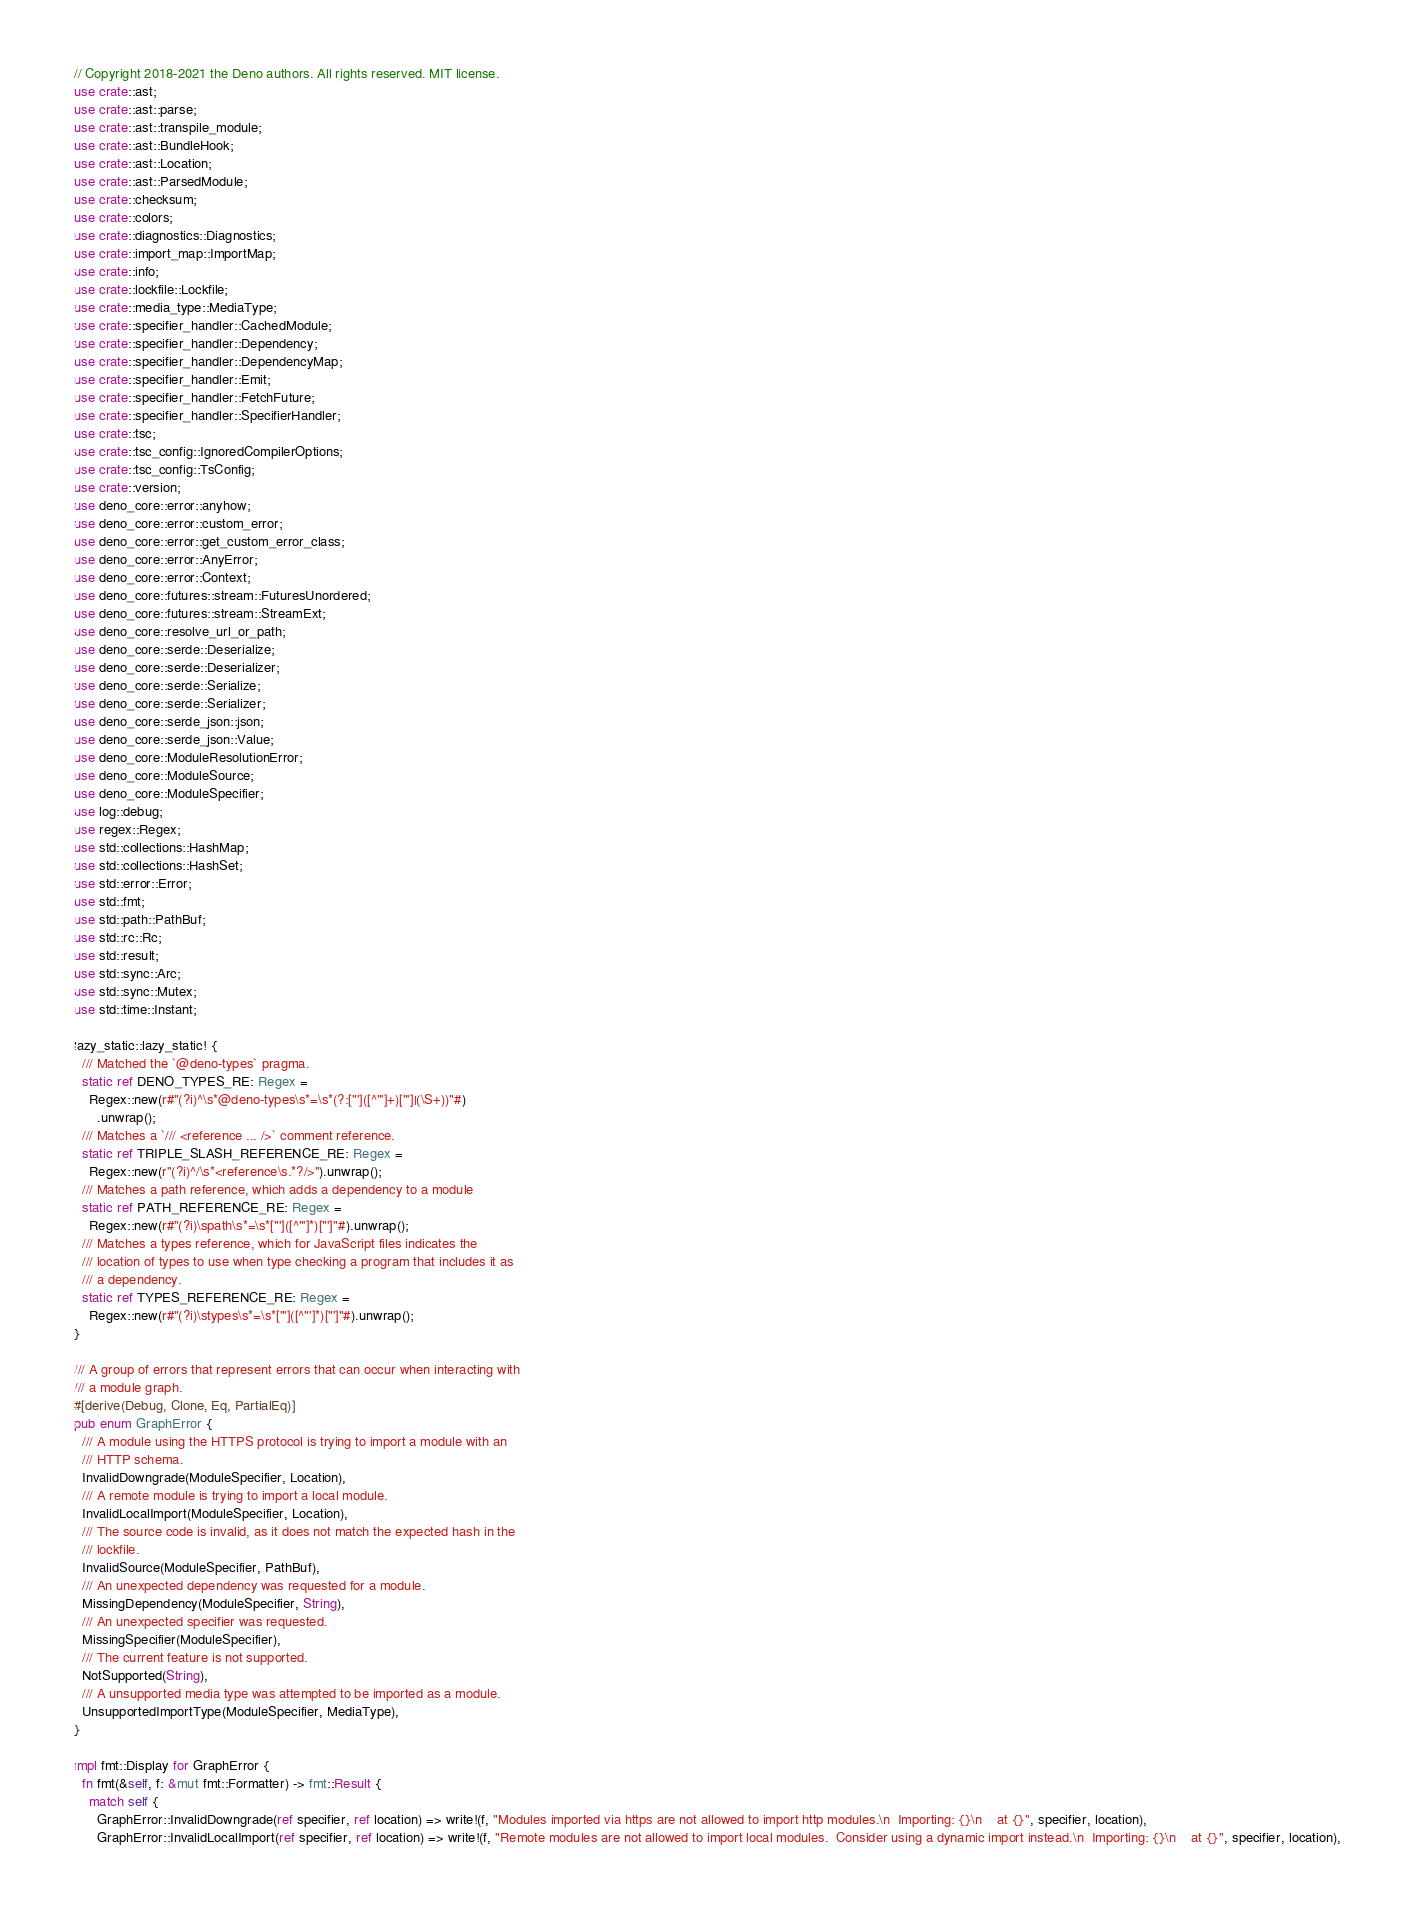Convert code to text. <code><loc_0><loc_0><loc_500><loc_500><_Rust_>// Copyright 2018-2021 the Deno authors. All rights reserved. MIT license.
use crate::ast;
use crate::ast::parse;
use crate::ast::transpile_module;
use crate::ast::BundleHook;
use crate::ast::Location;
use crate::ast::ParsedModule;
use crate::checksum;
use crate::colors;
use crate::diagnostics::Diagnostics;
use crate::import_map::ImportMap;
use crate::info;
use crate::lockfile::Lockfile;
use crate::media_type::MediaType;
use crate::specifier_handler::CachedModule;
use crate::specifier_handler::Dependency;
use crate::specifier_handler::DependencyMap;
use crate::specifier_handler::Emit;
use crate::specifier_handler::FetchFuture;
use crate::specifier_handler::SpecifierHandler;
use crate::tsc;
use crate::tsc_config::IgnoredCompilerOptions;
use crate::tsc_config::TsConfig;
use crate::version;
use deno_core::error::anyhow;
use deno_core::error::custom_error;
use deno_core::error::get_custom_error_class;
use deno_core::error::AnyError;
use deno_core::error::Context;
use deno_core::futures::stream::FuturesUnordered;
use deno_core::futures::stream::StreamExt;
use deno_core::resolve_url_or_path;
use deno_core::serde::Deserialize;
use deno_core::serde::Deserializer;
use deno_core::serde::Serialize;
use deno_core::serde::Serializer;
use deno_core::serde_json::json;
use deno_core::serde_json::Value;
use deno_core::ModuleResolutionError;
use deno_core::ModuleSource;
use deno_core::ModuleSpecifier;
use log::debug;
use regex::Regex;
use std::collections::HashMap;
use std::collections::HashSet;
use std::error::Error;
use std::fmt;
use std::path::PathBuf;
use std::rc::Rc;
use std::result;
use std::sync::Arc;
use std::sync::Mutex;
use std::time::Instant;

lazy_static::lazy_static! {
  /// Matched the `@deno-types` pragma.
  static ref DENO_TYPES_RE: Regex =
    Regex::new(r#"(?i)^\s*@deno-types\s*=\s*(?:["']([^"']+)["']|(\S+))"#)
      .unwrap();
  /// Matches a `/// <reference ... />` comment reference.
  static ref TRIPLE_SLASH_REFERENCE_RE: Regex =
    Regex::new(r"(?i)^/\s*<reference\s.*?/>").unwrap();
  /// Matches a path reference, which adds a dependency to a module
  static ref PATH_REFERENCE_RE: Regex =
    Regex::new(r#"(?i)\spath\s*=\s*["']([^"']*)["']"#).unwrap();
  /// Matches a types reference, which for JavaScript files indicates the
  /// location of types to use when type checking a program that includes it as
  /// a dependency.
  static ref TYPES_REFERENCE_RE: Regex =
    Regex::new(r#"(?i)\stypes\s*=\s*["']([^"']*)["']"#).unwrap();
}

/// A group of errors that represent errors that can occur when interacting with
/// a module graph.
#[derive(Debug, Clone, Eq, PartialEq)]
pub enum GraphError {
  /// A module using the HTTPS protocol is trying to import a module with an
  /// HTTP schema.
  InvalidDowngrade(ModuleSpecifier, Location),
  /// A remote module is trying to import a local module.
  InvalidLocalImport(ModuleSpecifier, Location),
  /// The source code is invalid, as it does not match the expected hash in the
  /// lockfile.
  InvalidSource(ModuleSpecifier, PathBuf),
  /// An unexpected dependency was requested for a module.
  MissingDependency(ModuleSpecifier, String),
  /// An unexpected specifier was requested.
  MissingSpecifier(ModuleSpecifier),
  /// The current feature is not supported.
  NotSupported(String),
  /// A unsupported media type was attempted to be imported as a module.
  UnsupportedImportType(ModuleSpecifier, MediaType),
}

impl fmt::Display for GraphError {
  fn fmt(&self, f: &mut fmt::Formatter) -> fmt::Result {
    match self {
      GraphError::InvalidDowngrade(ref specifier, ref location) => write!(f, "Modules imported via https are not allowed to import http modules.\n  Importing: {}\n    at {}", specifier, location),
      GraphError::InvalidLocalImport(ref specifier, ref location) => write!(f, "Remote modules are not allowed to import local modules.  Consider using a dynamic import instead.\n  Importing: {}\n    at {}", specifier, location),</code> 